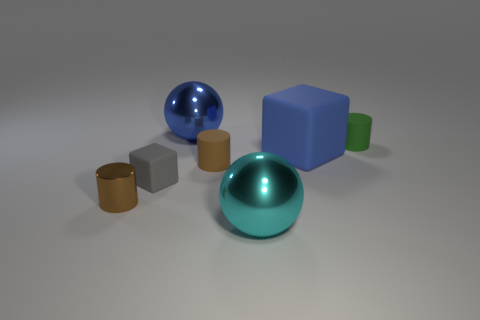Add 1 small purple objects. How many objects exist? 8 Subtract all brown metallic cylinders. How many cylinders are left? 2 Subtract all gray blocks. How many brown cylinders are left? 2 Subtract all cylinders. How many objects are left? 4 Subtract 1 blocks. How many blocks are left? 1 Subtract all blue blocks. How many blocks are left? 1 Subtract 0 green cubes. How many objects are left? 7 Subtract all blue cylinders. Subtract all yellow balls. How many cylinders are left? 3 Subtract all small yellow balls. Subtract all blue matte objects. How many objects are left? 6 Add 5 green rubber objects. How many green rubber objects are left? 6 